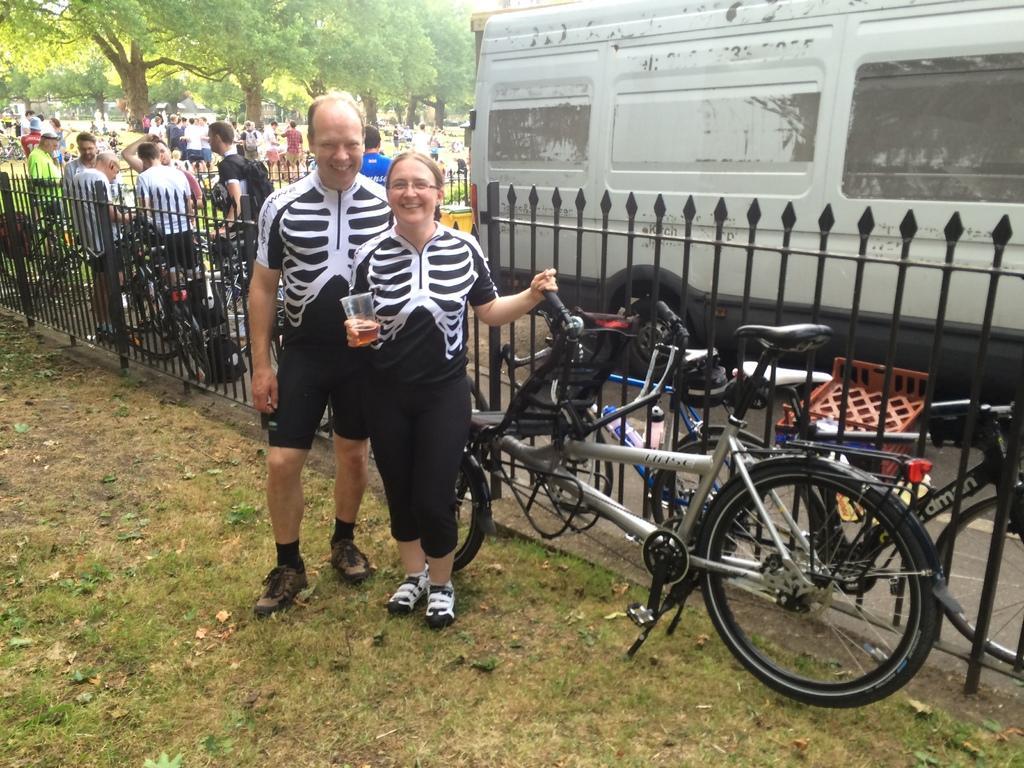Could you give a brief overview of what you see in this image? In this image I can see two persons standing wearing black and white dress and the person at right holding a glass and a bi-cycle. At the background I can see few persons standing, a vehicle and trees in green color. 